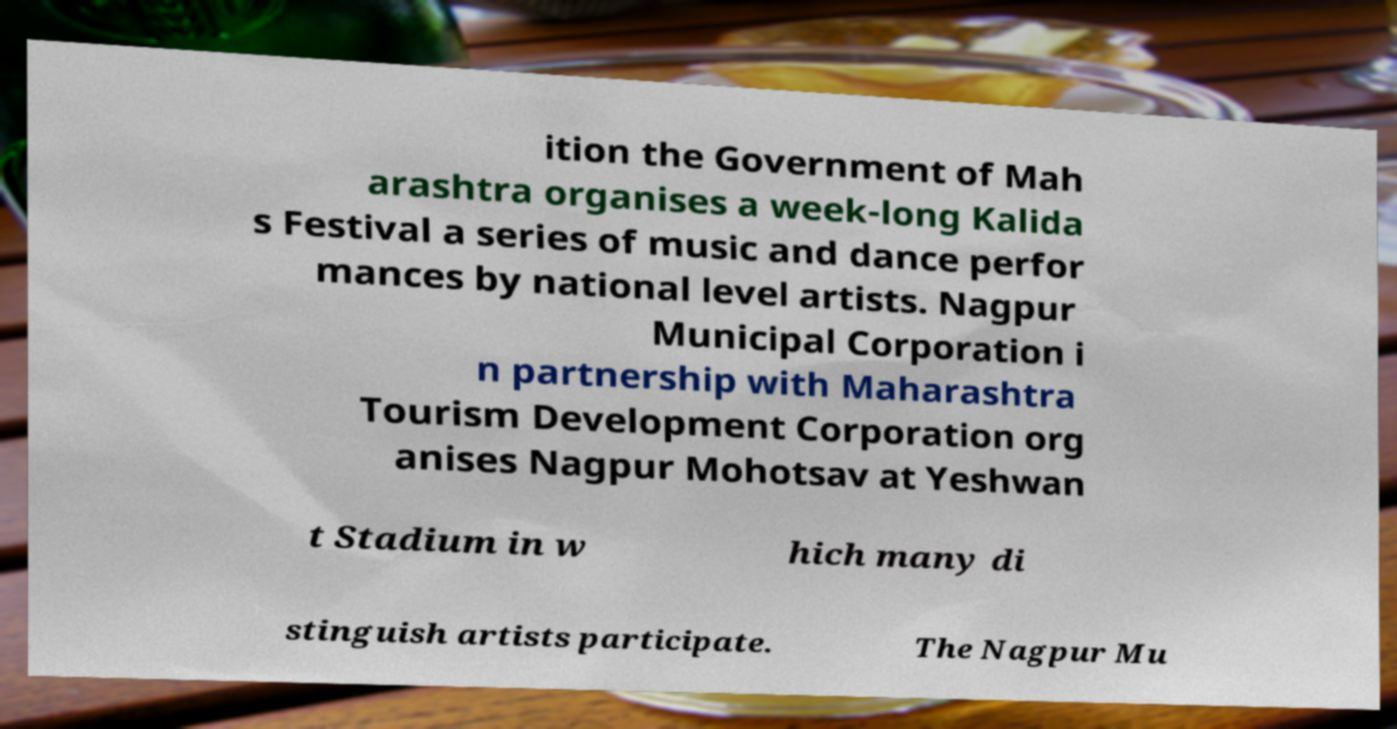Please identify and transcribe the text found in this image. ition the Government of Mah arashtra organises a week-long Kalida s Festival a series of music and dance perfor mances by national level artists. Nagpur Municipal Corporation i n partnership with Maharashtra Tourism Development Corporation org anises Nagpur Mohotsav at Yeshwan t Stadium in w hich many di stinguish artists participate. The Nagpur Mu 